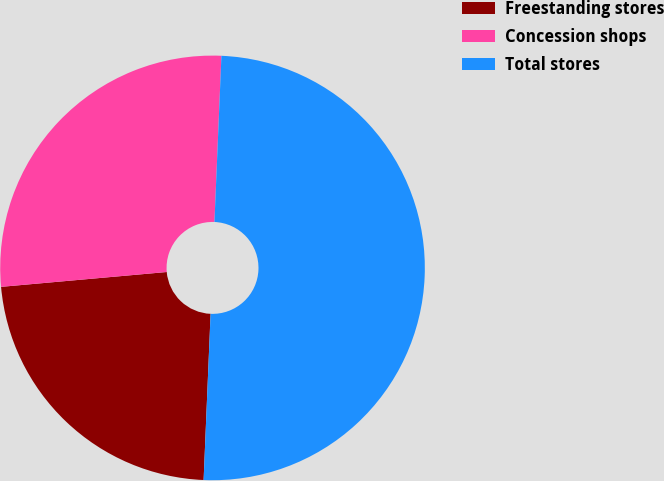Convert chart to OTSL. <chart><loc_0><loc_0><loc_500><loc_500><pie_chart><fcel>Freestanding stores<fcel>Concession shops<fcel>Total stores<nl><fcel>22.91%<fcel>27.09%<fcel>50.0%<nl></chart> 